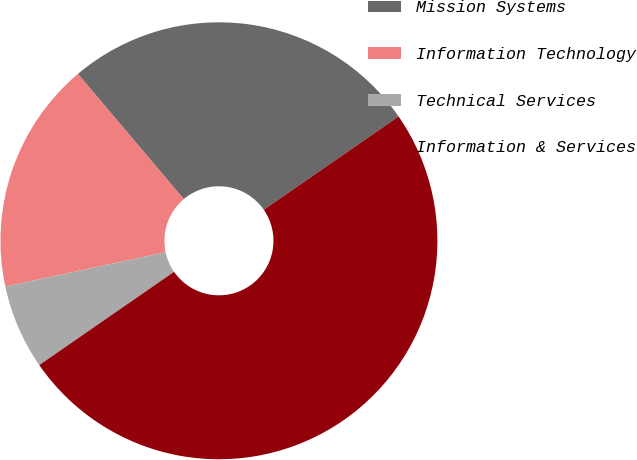Convert chart. <chart><loc_0><loc_0><loc_500><loc_500><pie_chart><fcel>Mission Systems<fcel>Information Technology<fcel>Technical Services<fcel>Information & Services<nl><fcel>26.54%<fcel>17.19%<fcel>6.27%<fcel>50.0%<nl></chart> 